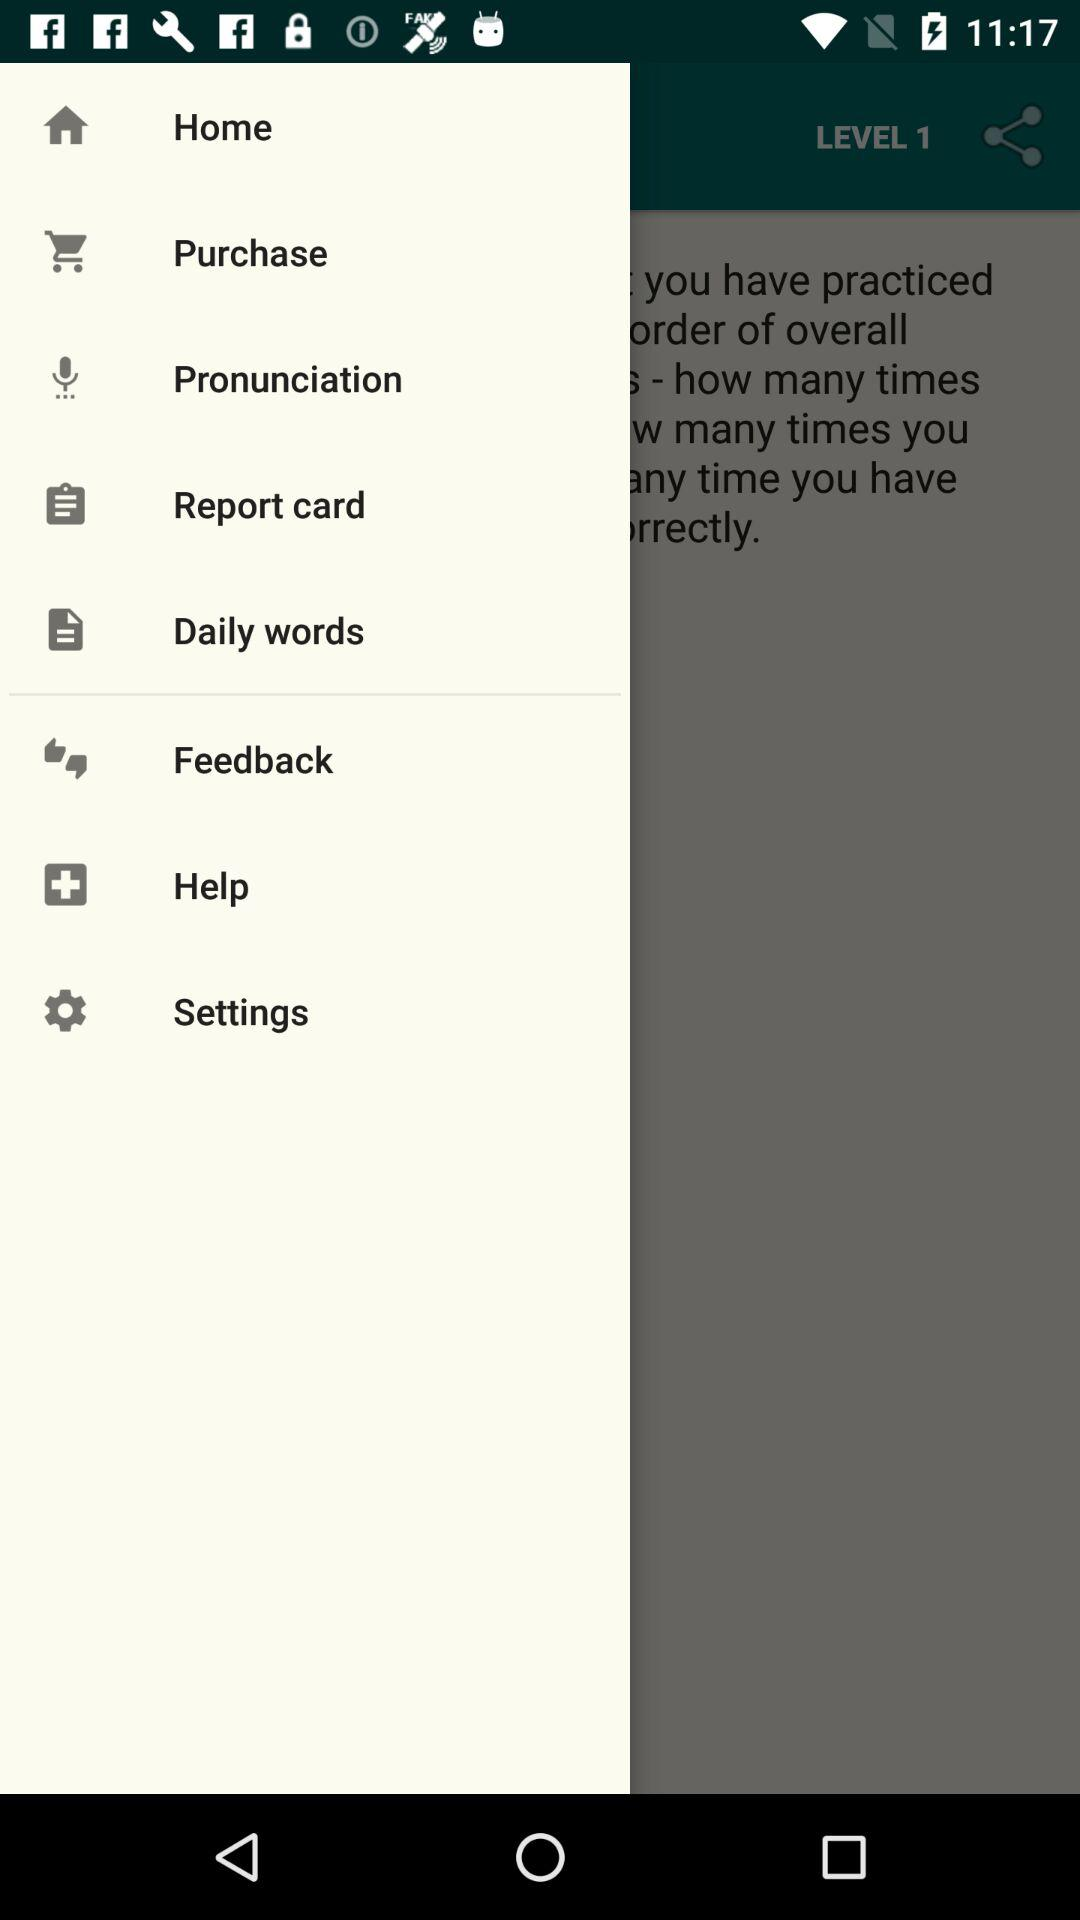How many items are in the menu bar?
Answer the question using a single word or phrase. 8 